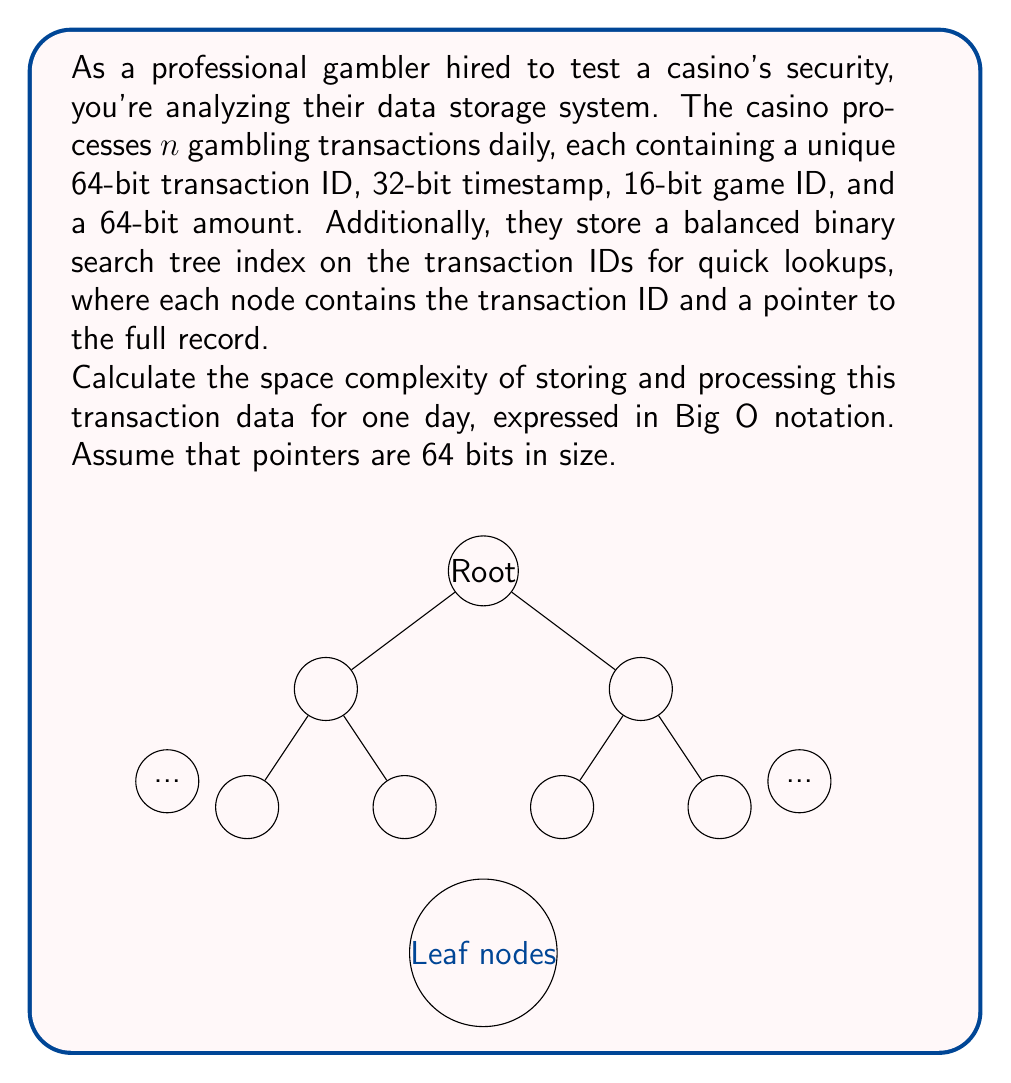Show me your answer to this math problem. Let's break down the space complexity analysis step-by-step:

1) Space for each transaction record:
   - Transaction ID: 64 bits
   - Timestamp: 32 bits
   - Game ID: 16 bits
   - Amount: 64 bits
   Total per record: 64 + 32 + 16 + 64 = 176 bits = 22 bytes

2) Space for all transaction records:
   $$22n$$ bytes, where $n$ is the number of transactions

3) Space for the binary search tree index:
   - Each node contains:
     * Transaction ID: 64 bits
     * Pointer to full record: 64 bits
     Total per node: 128 bits = 16 bytes
   - The tree has $n$ nodes (one for each transaction)
   Space for index: $$16n$$ bytes

4) Total space:
   $$22n + 16n = 38n$$ bytes

5) In Big O notation, we drop constants:
   $$O(n)$$ space complexity

The space complexity is linear in terms of the number of transactions, as both the transaction records and the index grow linearly with $n$.
Answer: $O(n)$ 